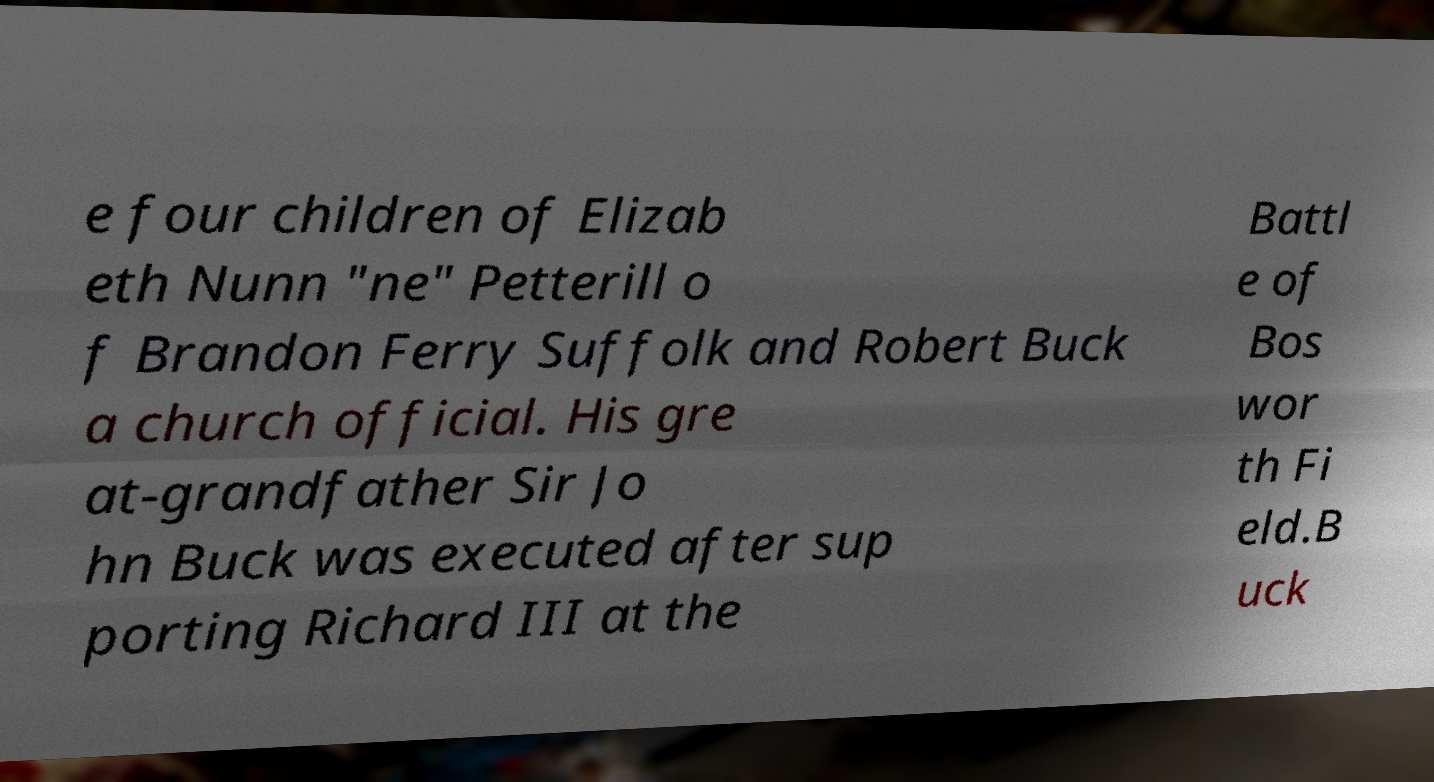What messages or text are displayed in this image? I need them in a readable, typed format. e four children of Elizab eth Nunn "ne" Petterill o f Brandon Ferry Suffolk and Robert Buck a church official. His gre at-grandfather Sir Jo hn Buck was executed after sup porting Richard III at the Battl e of Bos wor th Fi eld.B uck 